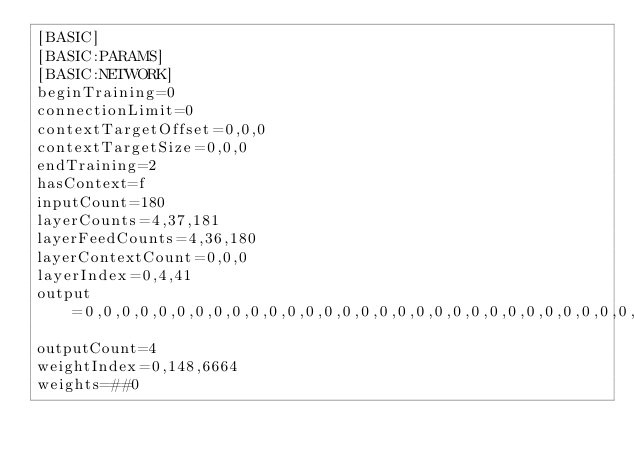Convert code to text. <code><loc_0><loc_0><loc_500><loc_500><_OCaml_>[BASIC]
[BASIC:PARAMS]
[BASIC:NETWORK]
beginTraining=0
connectionLimit=0
contextTargetOffset=0,0,0
contextTargetSize=0,0,0
endTraining=2
hasContext=f
inputCount=180
layerCounts=4,37,181
layerFeedCounts=4,36,180
layerContextCount=0,0,0
layerIndex=0,4,41
output=0,0,0,0,0,0,0,0,0,0,0,0,0,0,0,0,0,0,0,0,0,0,0,0,0,0,0,0,0,0,0,0,0,0,0,0,0,0,0,0,1,0,0,0,0,0,0,0,0,0,0,0,0,0,0,0,0,0,0,0,0,0,0,0,0,0,0,0,0,0,0,0,0,0,0,0,0,0,0,0,0,0,0,0,0,0,0,0,0,0,0,0,0,0,0,0,0,0,0,0,0,0,0,0,0,0,0,0,0,0,0,0,0,0,0,0,0,0,0,0,0,0,0,0,0,0,0,0,0,0,0,0,0,0,0,0,0,0,0,0,0,0,0,0,0,0,0,0,0,0,0,0,0,0,0,0,0,0,0,0,0,0,0,0,0,0,0,0,0,0,0,0,0,0,0,0,0,0,0,0,0,0,0,0,0,0,0,0,0,0,0,0,0,0,0,0,0,0,0,0,0,0,0,0,0,0,0,0,0,0,0,0,0,0,0,0,0,0,0,0,0,1
outputCount=4
weightIndex=0,148,6664
weights=##0</code> 